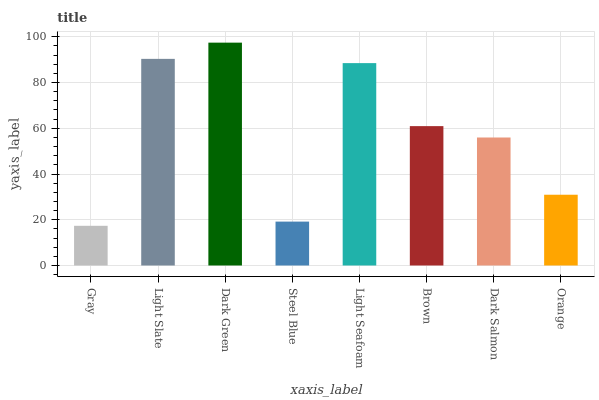Is Light Slate the minimum?
Answer yes or no. No. Is Light Slate the maximum?
Answer yes or no. No. Is Light Slate greater than Gray?
Answer yes or no. Yes. Is Gray less than Light Slate?
Answer yes or no. Yes. Is Gray greater than Light Slate?
Answer yes or no. No. Is Light Slate less than Gray?
Answer yes or no. No. Is Brown the high median?
Answer yes or no. Yes. Is Dark Salmon the low median?
Answer yes or no. Yes. Is Dark Green the high median?
Answer yes or no. No. Is Dark Green the low median?
Answer yes or no. No. 